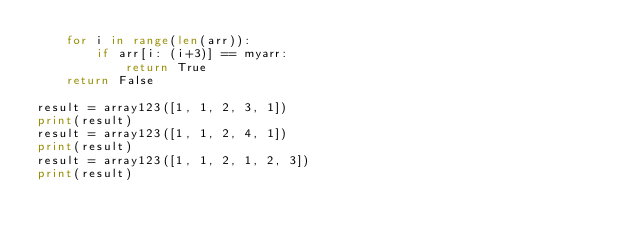Convert code to text. <code><loc_0><loc_0><loc_500><loc_500><_Python_>    for i in range(len(arr)):
        if arr[i: (i+3)] == myarr:
            return True
    return False

result = array123([1, 1, 2, 3, 1])
print(result)
result = array123([1, 1, 2, 4, 1])
print(result)
result = array123([1, 1, 2, 1, 2, 3])
print(result)</code> 